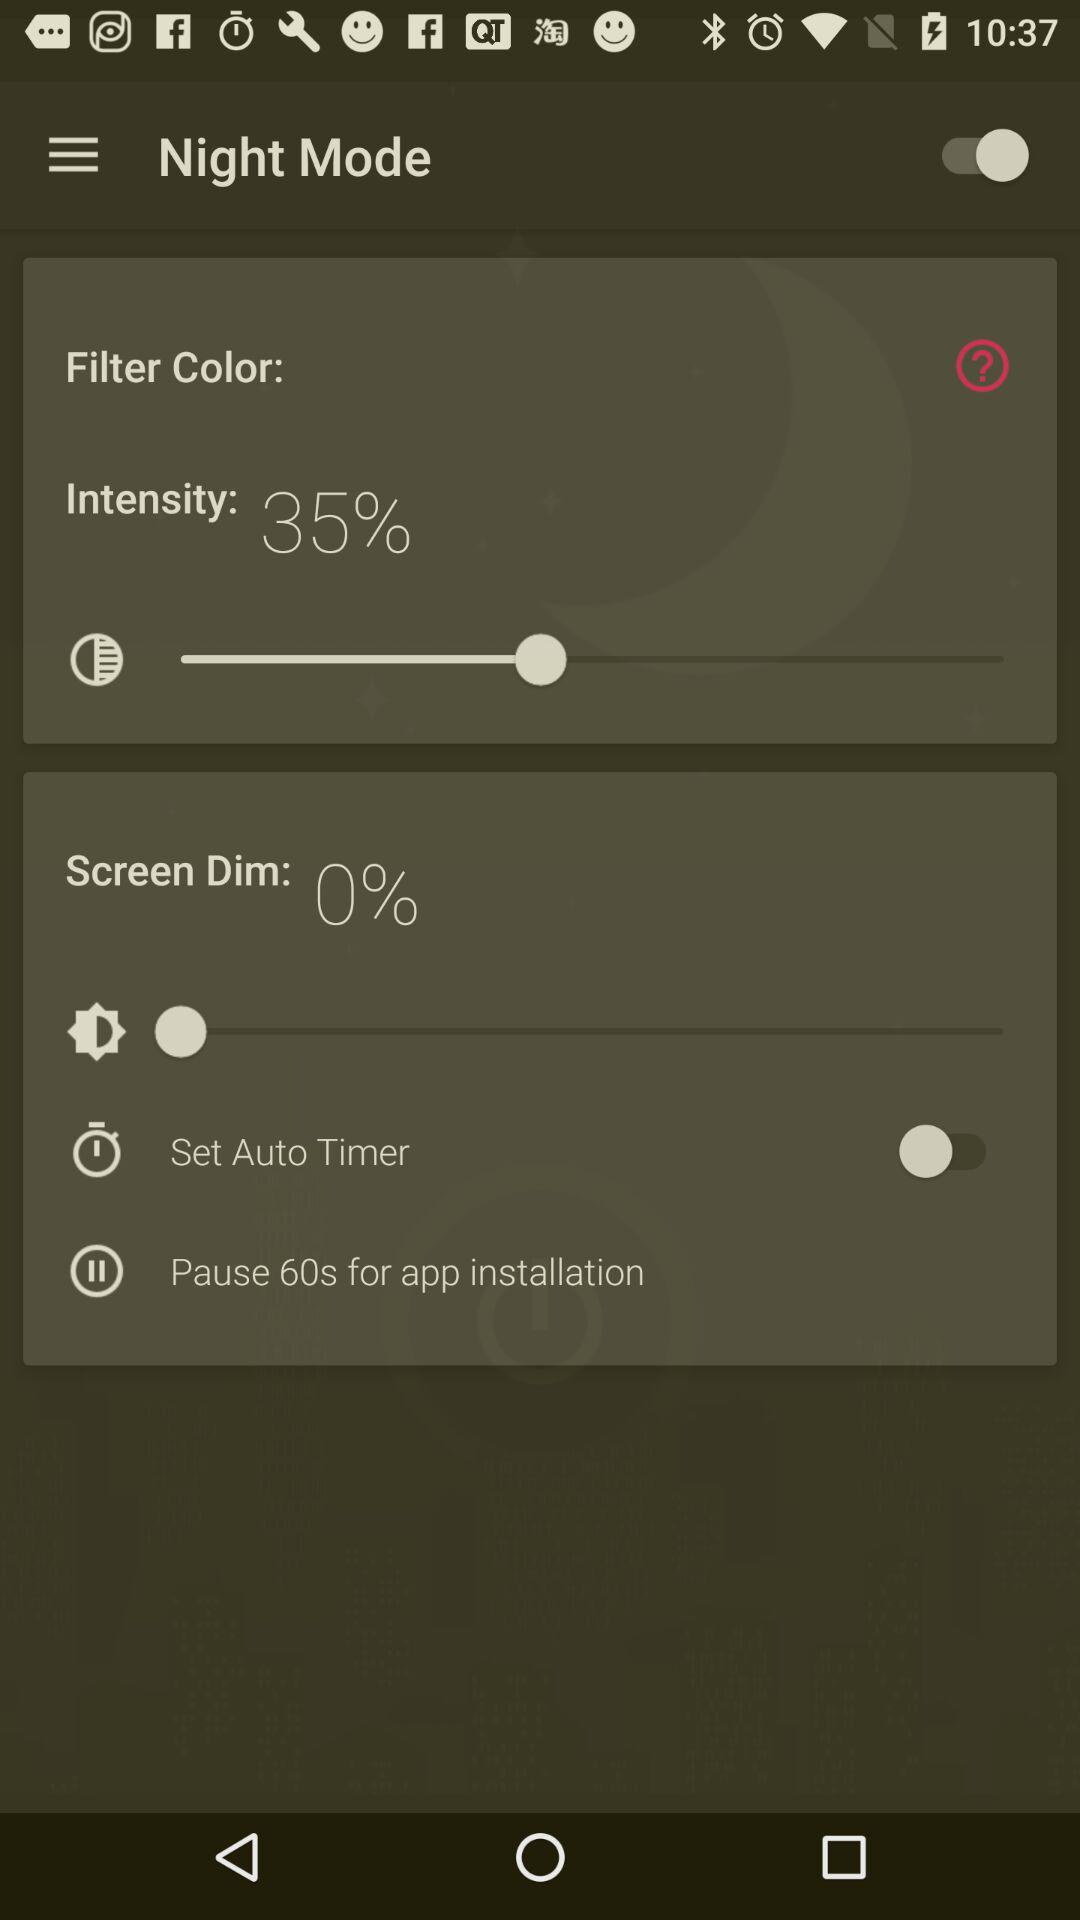What is the status of "Night Mode"? The status is "on". 